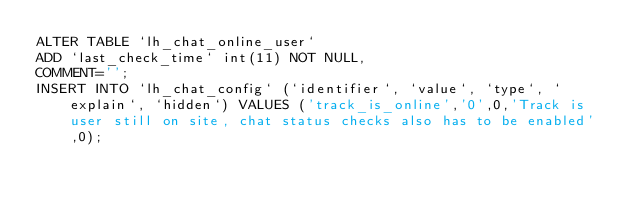Convert code to text. <code><loc_0><loc_0><loc_500><loc_500><_SQL_>ALTER TABLE `lh_chat_online_user`
ADD `last_check_time` int(11) NOT NULL,
COMMENT='';
INSERT INTO `lh_chat_config` (`identifier`, `value`, `type`, `explain`, `hidden`) VALUES ('track_is_online','0',0,'Track is user still on site, chat status checks also has to be enabled',0);</code> 